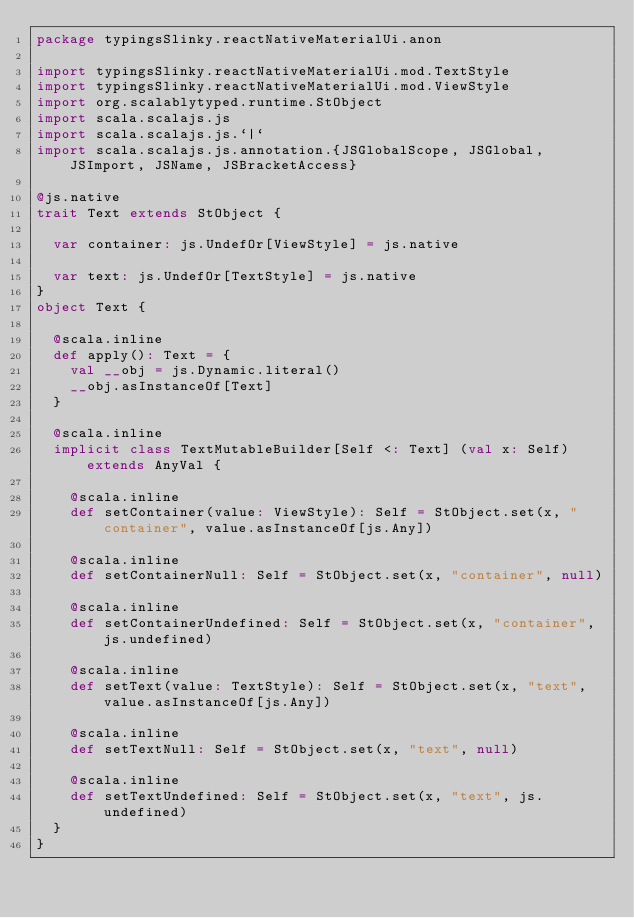Convert code to text. <code><loc_0><loc_0><loc_500><loc_500><_Scala_>package typingsSlinky.reactNativeMaterialUi.anon

import typingsSlinky.reactNativeMaterialUi.mod.TextStyle
import typingsSlinky.reactNativeMaterialUi.mod.ViewStyle
import org.scalablytyped.runtime.StObject
import scala.scalajs.js
import scala.scalajs.js.`|`
import scala.scalajs.js.annotation.{JSGlobalScope, JSGlobal, JSImport, JSName, JSBracketAccess}

@js.native
trait Text extends StObject {
  
  var container: js.UndefOr[ViewStyle] = js.native
  
  var text: js.UndefOr[TextStyle] = js.native
}
object Text {
  
  @scala.inline
  def apply(): Text = {
    val __obj = js.Dynamic.literal()
    __obj.asInstanceOf[Text]
  }
  
  @scala.inline
  implicit class TextMutableBuilder[Self <: Text] (val x: Self) extends AnyVal {
    
    @scala.inline
    def setContainer(value: ViewStyle): Self = StObject.set(x, "container", value.asInstanceOf[js.Any])
    
    @scala.inline
    def setContainerNull: Self = StObject.set(x, "container", null)
    
    @scala.inline
    def setContainerUndefined: Self = StObject.set(x, "container", js.undefined)
    
    @scala.inline
    def setText(value: TextStyle): Self = StObject.set(x, "text", value.asInstanceOf[js.Any])
    
    @scala.inline
    def setTextNull: Self = StObject.set(x, "text", null)
    
    @scala.inline
    def setTextUndefined: Self = StObject.set(x, "text", js.undefined)
  }
}
</code> 